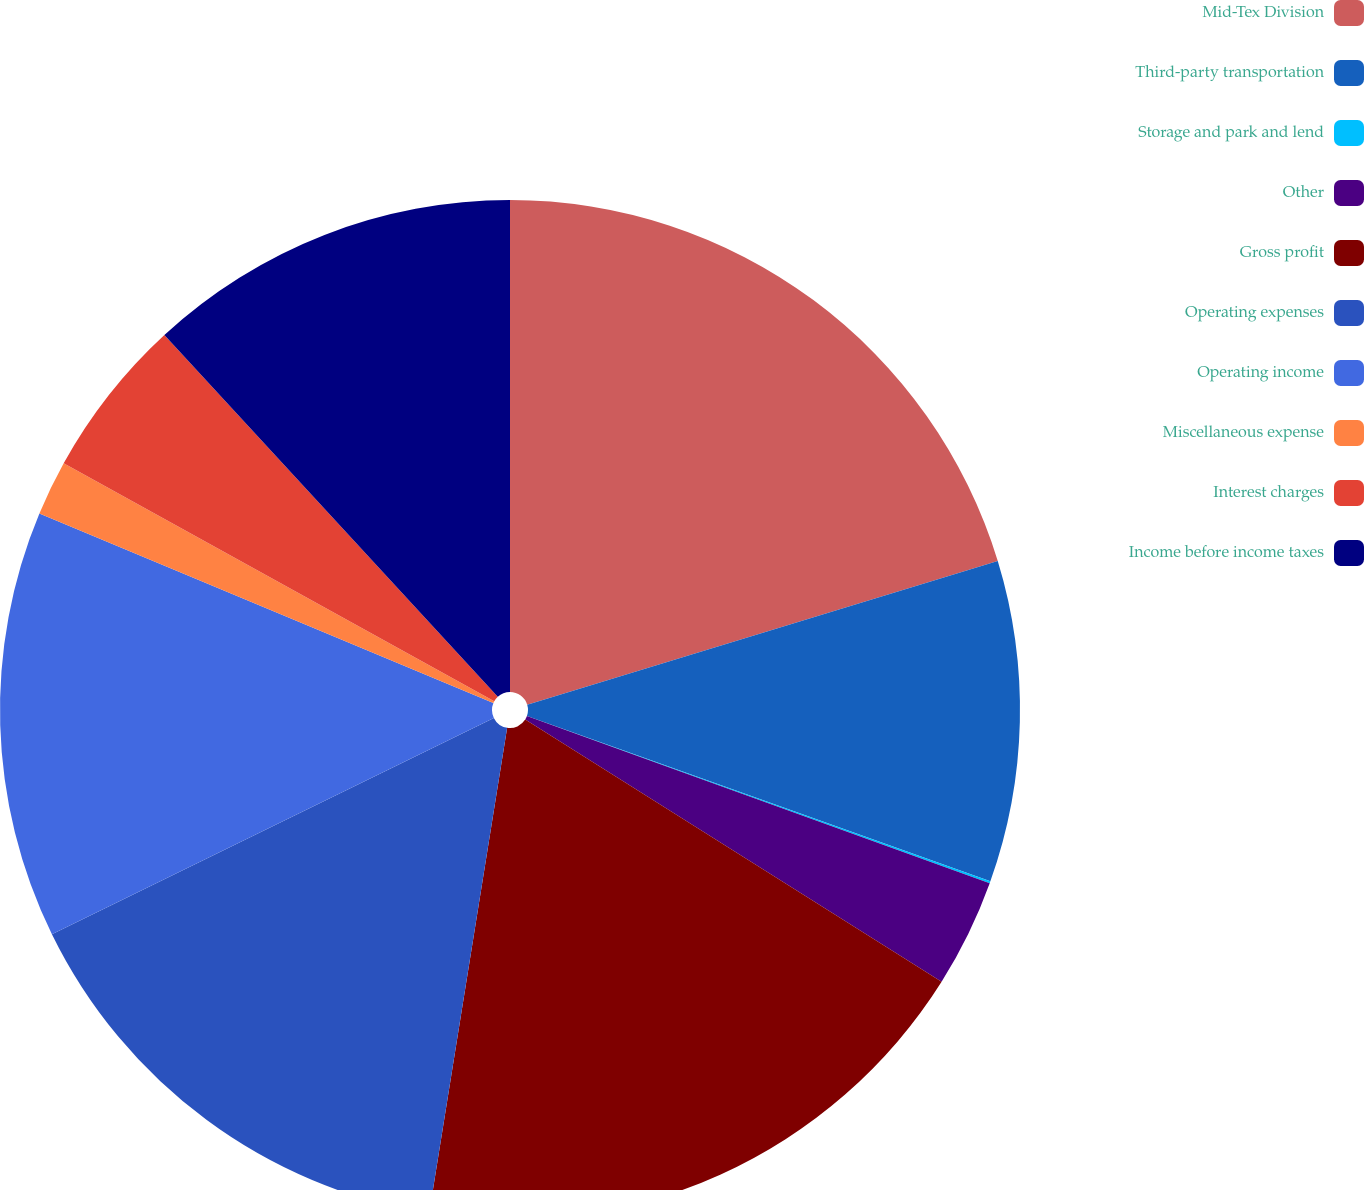Convert chart to OTSL. <chart><loc_0><loc_0><loc_500><loc_500><pie_chart><fcel>Mid-Tex Division<fcel>Third-party transportation<fcel>Storage and park and lend<fcel>Other<fcel>Gross profit<fcel>Operating expenses<fcel>Operating income<fcel>Miscellaneous expense<fcel>Interest charges<fcel>Income before income taxes<nl><fcel>20.28%<fcel>10.17%<fcel>0.06%<fcel>3.43%<fcel>18.59%<fcel>15.22%<fcel>13.54%<fcel>1.74%<fcel>5.11%<fcel>11.85%<nl></chart> 